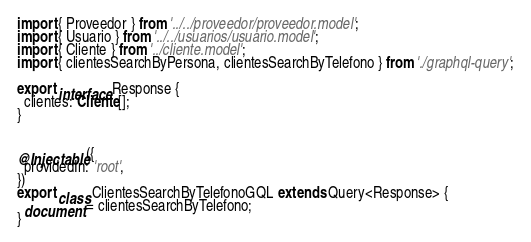<code> <loc_0><loc_0><loc_500><loc_500><_TypeScript_>import { Proveedor } from '../../proveedor/proveedor.model';
import { Usuario } from '../../usuarios/usuario.model';
import { Cliente } from '../cliente.model';
import { clientesSearchByPersona, clientesSearchByTelefono } from './graphql-query';

export interface Response {
  clientes: Cliente[];
}


@Injectable({
  providedIn: 'root',
})
export class ClientesSearchByTelefonoGQL extends Query<Response> {
  document = clientesSearchByTelefono;
}
</code> 